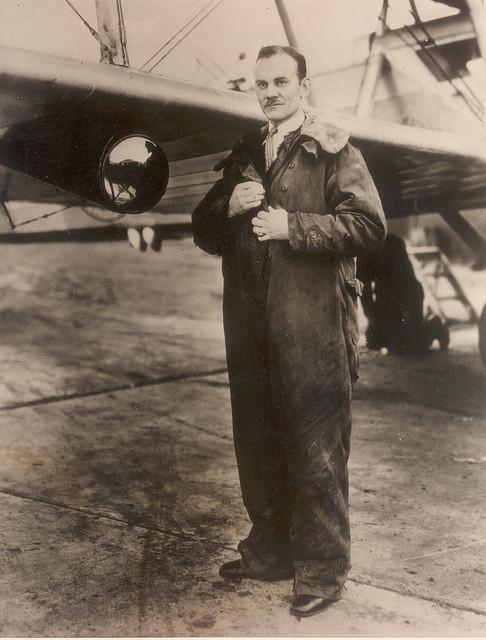How many people can be seen?
Give a very brief answer. 2. How many kids are holding a laptop on their lap ?
Give a very brief answer. 0. 